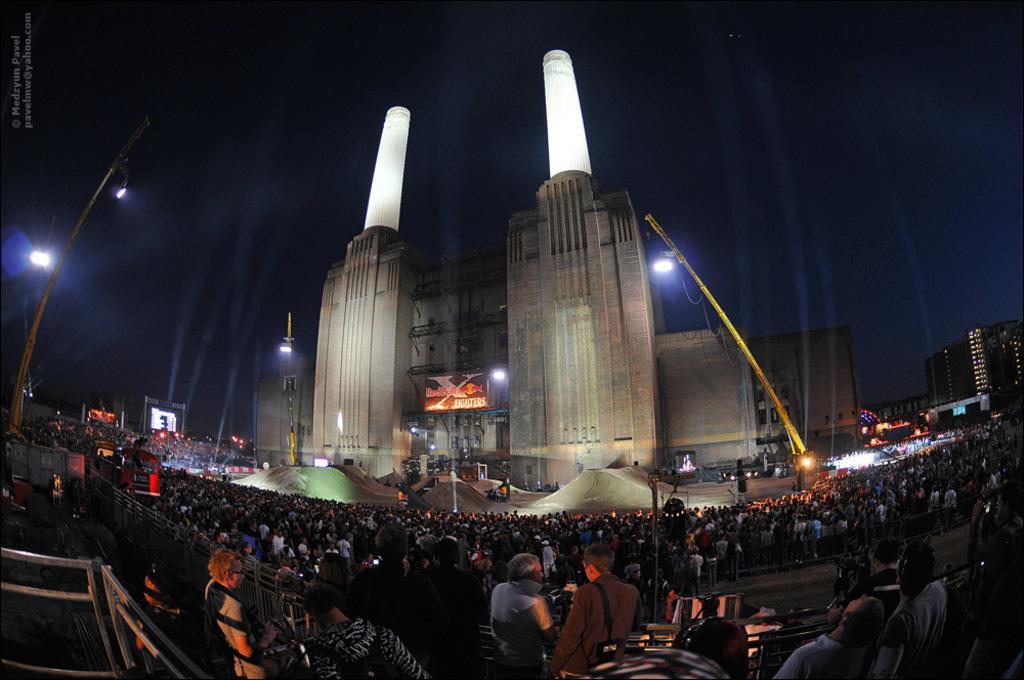Can you describe this image briefly? In this image, in the middle, we can see a group of people. In the left corner, we can see a metal rod. In the background, we can see some buildings, tower, pole, lights. At the top, we can see black color. 